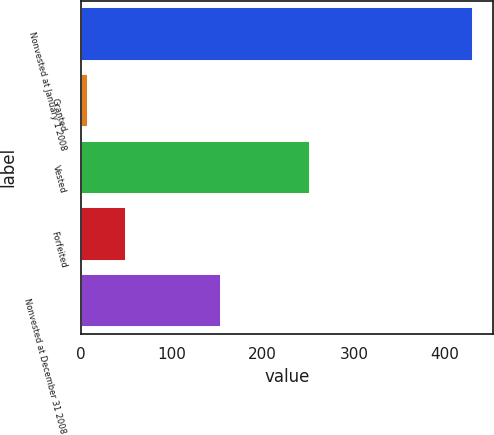Convert chart. <chart><loc_0><loc_0><loc_500><loc_500><bar_chart><fcel>Nonvested at January 1 2008<fcel>Granted<fcel>Vested<fcel>Forfeited<fcel>Nonvested at December 31 2008<nl><fcel>431<fcel>8<fcel>252<fcel>50.3<fcel>154<nl></chart> 